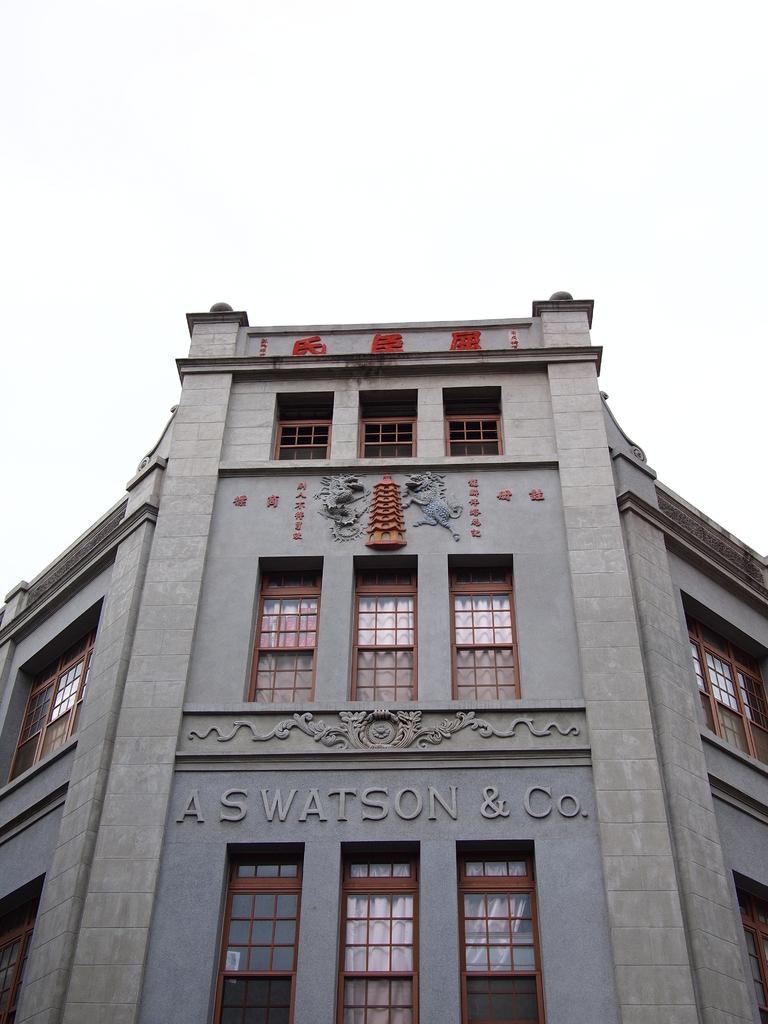What is the main subject of the picture? The main subject of the picture is a building. What specific features can be seen on the building? The building has windows. What can be seen in the background of the picture? The sky is visible in the background of the picture. What type of locket can be seen hanging from the building in the image? There is no locket present in the image; it features a building with windows and a visible sky in the background. 